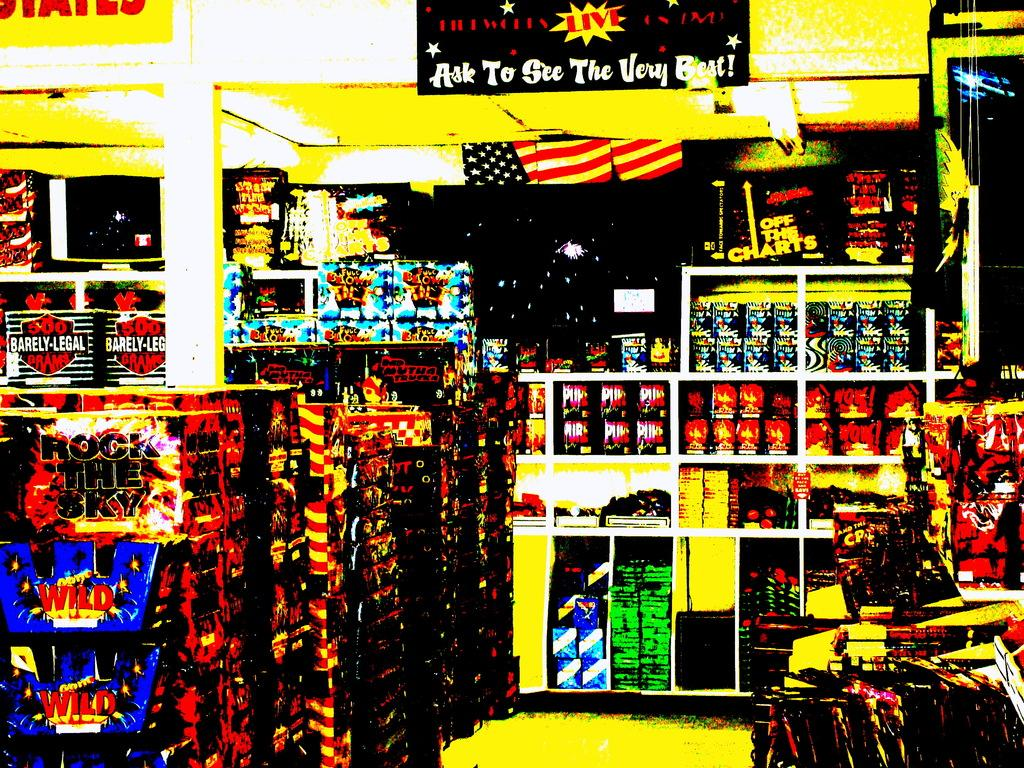<image>
Give a short and clear explanation of the subsequent image. A sign on the wall at the top of the store reads Ask to see the very best. 